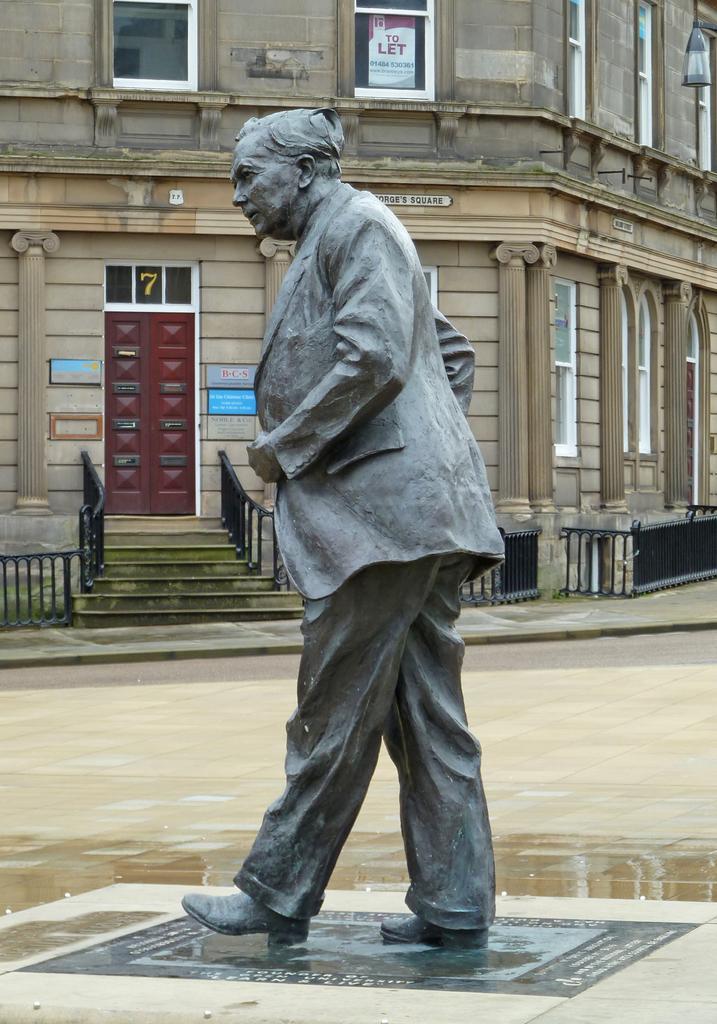Describe this image in one or two sentences. In this image I can see a statue of a person which is black in color on the floor. In the background I can see few stairs, the black colored railing, the building which is cream and brown in color, few windows which are white in color and the door which is maroon in color. 